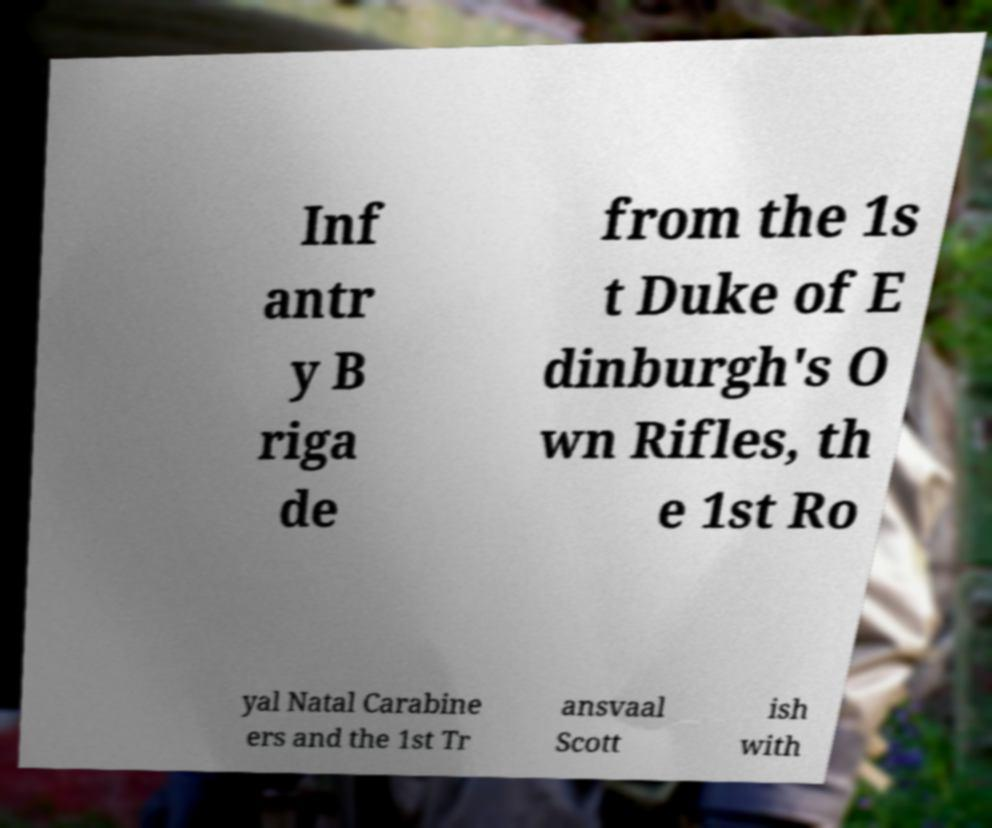Can you read and provide the text displayed in the image?This photo seems to have some interesting text. Can you extract and type it out for me? Inf antr y B riga de from the 1s t Duke of E dinburgh's O wn Rifles, th e 1st Ro yal Natal Carabine ers and the 1st Tr ansvaal Scott ish with 